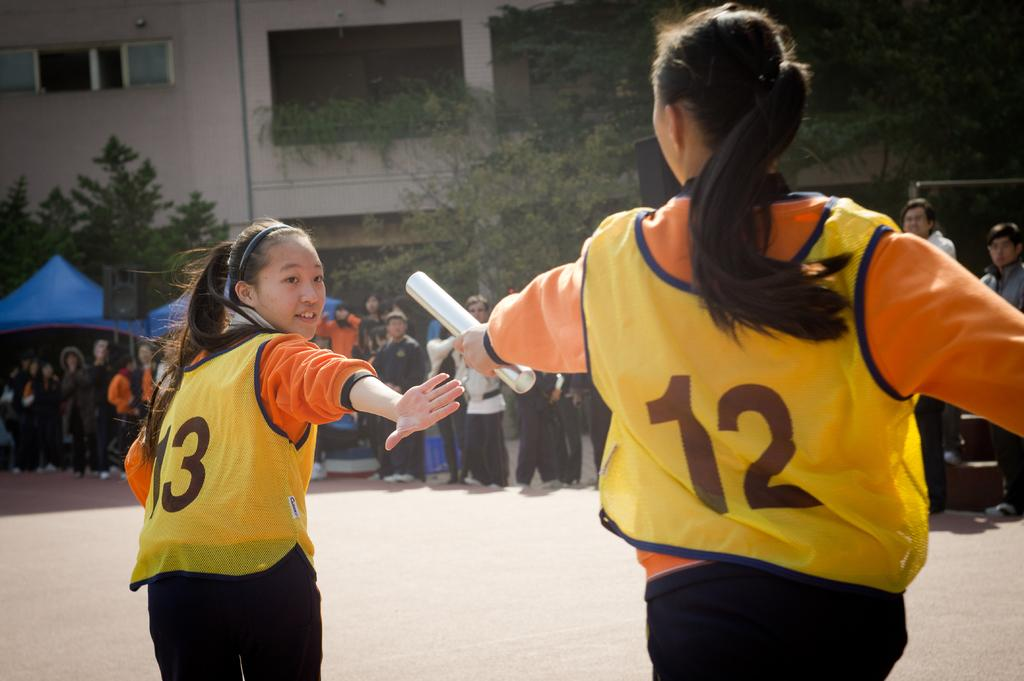<image>
Create a compact narrative representing the image presented. Female relay racer number 12 handing off a metal cylinder to female racer number 13 in front of a crowd. 